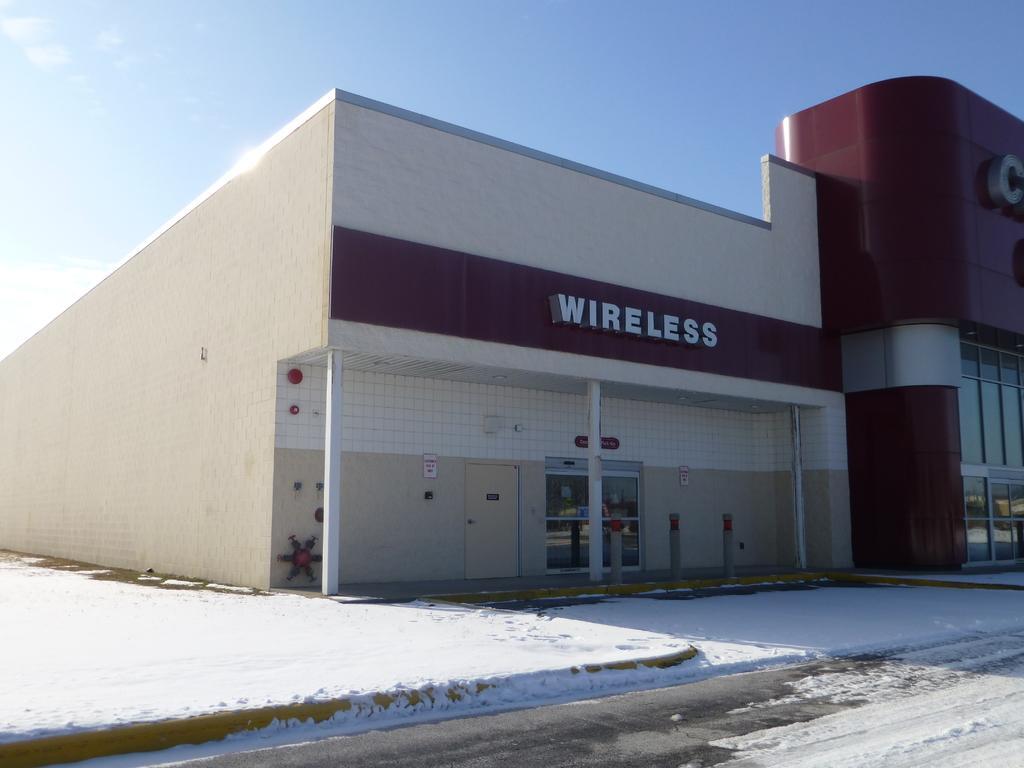Can you describe this image briefly? In this picture we can see a building, at the bottom there is snow, we can see a door and glass in the middle, we can also see pillars, there is the sky at the top of the picture. 